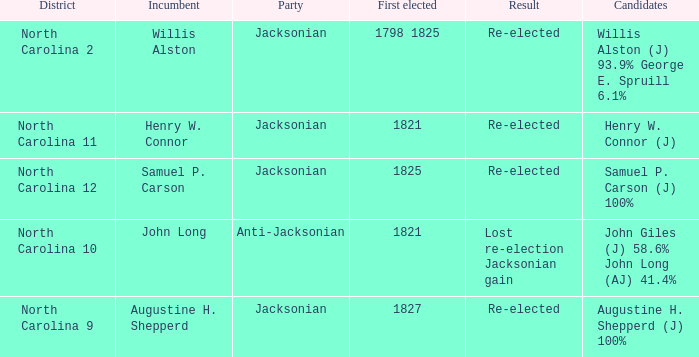State the entire quantity of events for willis alston. 1.0. 